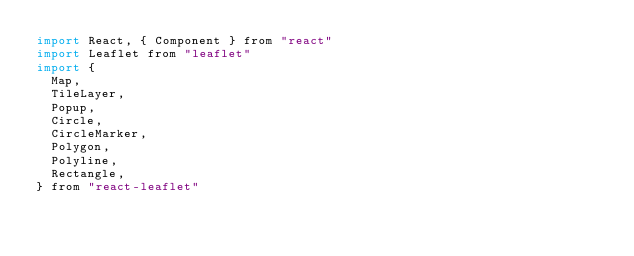Convert code to text. <code><loc_0><loc_0><loc_500><loc_500><_JavaScript_>import React, { Component } from "react"
import Leaflet from "leaflet"
import {
  Map,
  TileLayer,
  Popup,
  Circle,
  CircleMarker,
  Polygon,
  Polyline,
  Rectangle,
} from "react-leaflet"</code> 